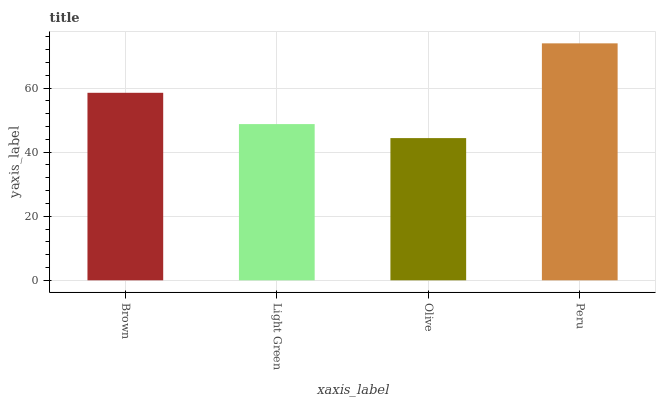Is Olive the minimum?
Answer yes or no. Yes. Is Peru the maximum?
Answer yes or no. Yes. Is Light Green the minimum?
Answer yes or no. No. Is Light Green the maximum?
Answer yes or no. No. Is Brown greater than Light Green?
Answer yes or no. Yes. Is Light Green less than Brown?
Answer yes or no. Yes. Is Light Green greater than Brown?
Answer yes or no. No. Is Brown less than Light Green?
Answer yes or no. No. Is Brown the high median?
Answer yes or no. Yes. Is Light Green the low median?
Answer yes or no. Yes. Is Olive the high median?
Answer yes or no. No. Is Brown the low median?
Answer yes or no. No. 